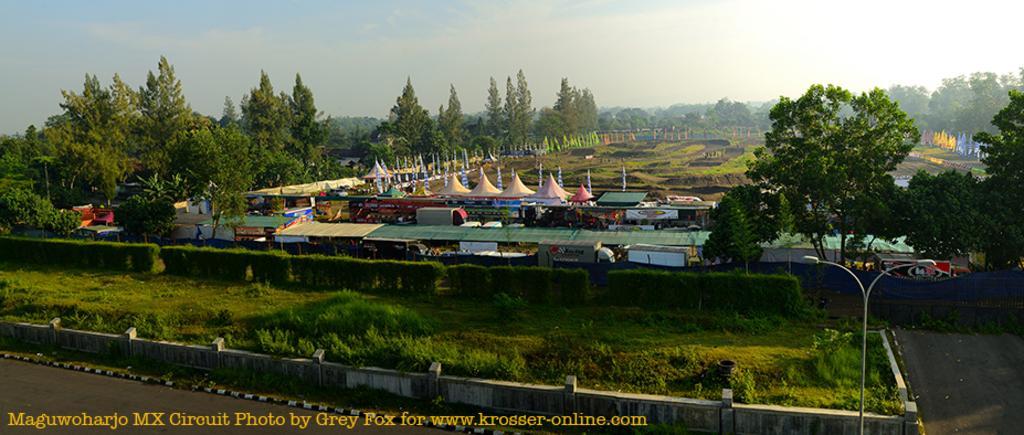In one or two sentences, can you explain what this image depicts? In this image I can see few trees in green color and I can see few stalls and tents. In the background the sky is in blue and white color. 